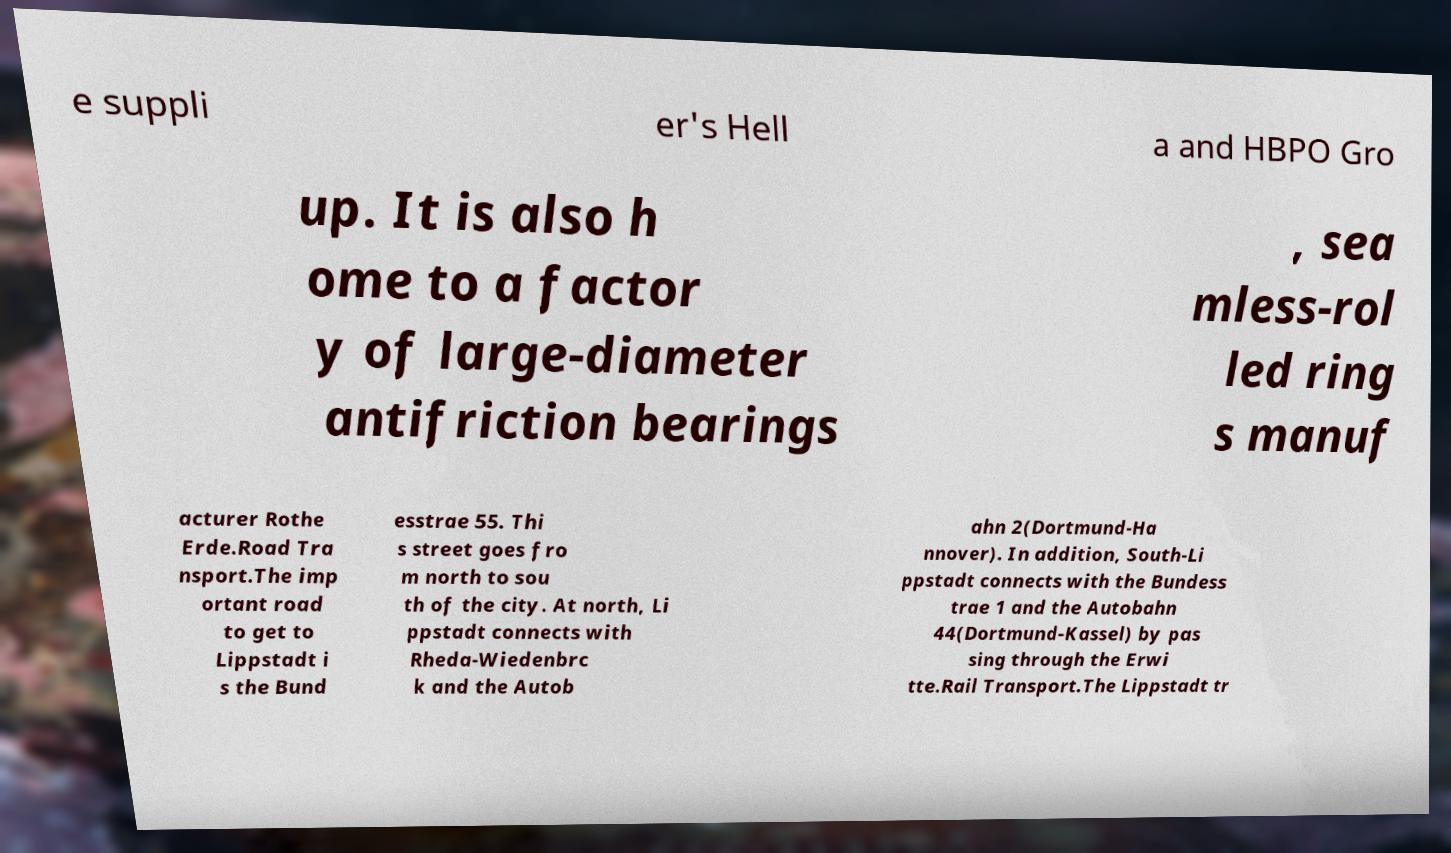Can you accurately transcribe the text from the provided image for me? e suppli er's Hell a and HBPO Gro up. It is also h ome to a factor y of large-diameter antifriction bearings , sea mless-rol led ring s manuf acturer Rothe Erde.Road Tra nsport.The imp ortant road to get to Lippstadt i s the Bund esstrae 55. Thi s street goes fro m north to sou th of the city. At north, Li ppstadt connects with Rheda-Wiedenbrc k and the Autob ahn 2(Dortmund-Ha nnover). In addition, South-Li ppstadt connects with the Bundess trae 1 and the Autobahn 44(Dortmund-Kassel) by pas sing through the Erwi tte.Rail Transport.The Lippstadt tr 